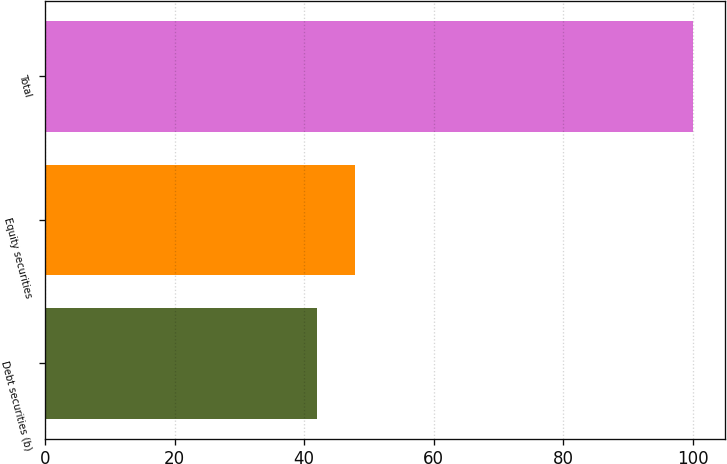Convert chart to OTSL. <chart><loc_0><loc_0><loc_500><loc_500><bar_chart><fcel>Debt securities (b)<fcel>Equity securities<fcel>Total<nl><fcel>42<fcel>47.8<fcel>100<nl></chart> 